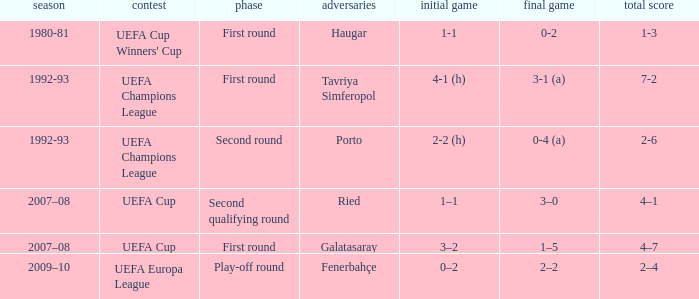 what's the 1st leg where opponents is galatasaray 3–2. 